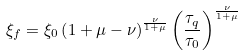Convert formula to latex. <formula><loc_0><loc_0><loc_500><loc_500>\xi _ { f } = \xi _ { 0 } \left ( 1 + \mu - \nu \right ) ^ { \frac { \nu } { 1 + \mu } } \left ( \frac { \tau _ { q } } { \tau _ { 0 } } \right ) ^ { \frac { \nu } { 1 + \mu } }</formula> 